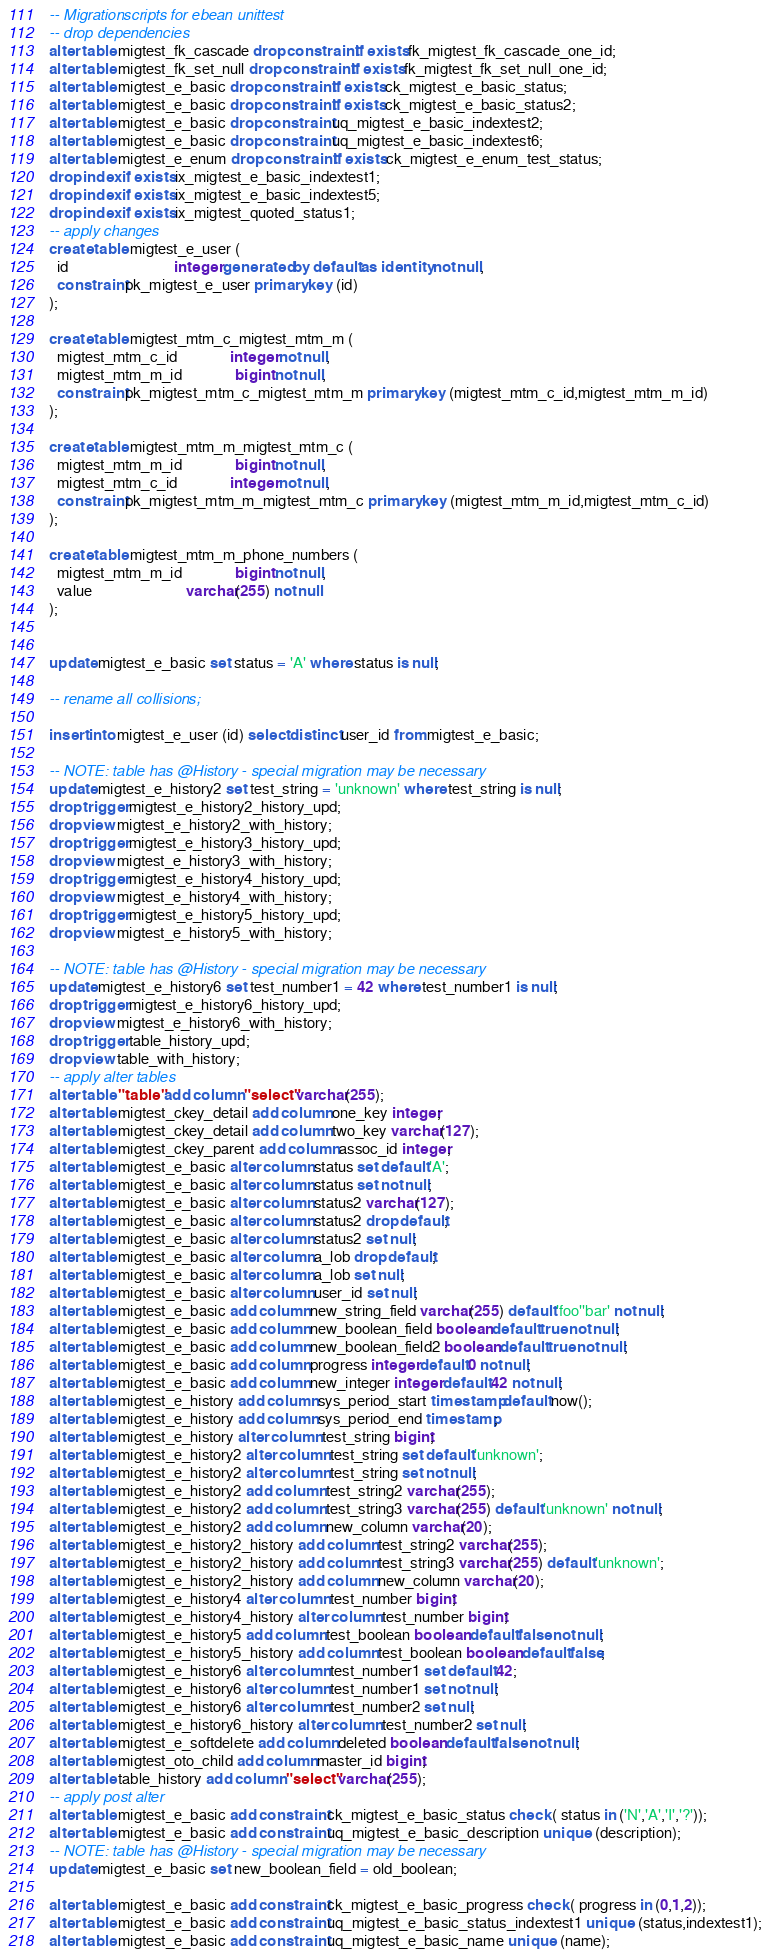Convert code to text. <code><loc_0><loc_0><loc_500><loc_500><_SQL_>-- Migrationscripts for ebean unittest
-- drop dependencies
alter table migtest_fk_cascade drop constraint if exists fk_migtest_fk_cascade_one_id;
alter table migtest_fk_set_null drop constraint if exists fk_migtest_fk_set_null_one_id;
alter table migtest_e_basic drop constraint if exists ck_migtest_e_basic_status;
alter table migtest_e_basic drop constraint if exists ck_migtest_e_basic_status2;
alter table migtest_e_basic drop constraint uq_migtest_e_basic_indextest2;
alter table migtest_e_basic drop constraint uq_migtest_e_basic_indextest6;
alter table migtest_e_enum drop constraint if exists ck_migtest_e_enum_test_status;
drop index if exists ix_migtest_e_basic_indextest1;
drop index if exists ix_migtest_e_basic_indextest5;
drop index if exists ix_migtest_quoted_status1;
-- apply changes
create table migtest_e_user (
  id                            integer generated by default as identity not null,
  constraint pk_migtest_e_user primary key (id)
);

create table migtest_mtm_c_migtest_mtm_m (
  migtest_mtm_c_id              integer not null,
  migtest_mtm_m_id              bigint not null,
  constraint pk_migtest_mtm_c_migtest_mtm_m primary key (migtest_mtm_c_id,migtest_mtm_m_id)
);

create table migtest_mtm_m_migtest_mtm_c (
  migtest_mtm_m_id              bigint not null,
  migtest_mtm_c_id              integer not null,
  constraint pk_migtest_mtm_m_migtest_mtm_c primary key (migtest_mtm_m_id,migtest_mtm_c_id)
);

create table migtest_mtm_m_phone_numbers (
  migtest_mtm_m_id              bigint not null,
  value                         varchar(255) not null
);


update migtest_e_basic set status = 'A' where status is null;

-- rename all collisions;

insert into migtest_e_user (id) select distinct user_id from migtest_e_basic;

-- NOTE: table has @History - special migration may be necessary
update migtest_e_history2 set test_string = 'unknown' where test_string is null;
drop trigger migtest_e_history2_history_upd;
drop view migtest_e_history2_with_history;
drop trigger migtest_e_history3_history_upd;
drop view migtest_e_history3_with_history;
drop trigger migtest_e_history4_history_upd;
drop view migtest_e_history4_with_history;
drop trigger migtest_e_history5_history_upd;
drop view migtest_e_history5_with_history;

-- NOTE: table has @History - special migration may be necessary
update migtest_e_history6 set test_number1 = 42 where test_number1 is null;
drop trigger migtest_e_history6_history_upd;
drop view migtest_e_history6_with_history;
drop trigger table_history_upd;
drop view table_with_history;
-- apply alter tables
alter table "table" add column "select" varchar(255);
alter table migtest_ckey_detail add column one_key integer;
alter table migtest_ckey_detail add column two_key varchar(127);
alter table migtest_ckey_parent add column assoc_id integer;
alter table migtest_e_basic alter column status set default 'A';
alter table migtest_e_basic alter column status set not null;
alter table migtest_e_basic alter column status2 varchar(127);
alter table migtest_e_basic alter column status2 drop default;
alter table migtest_e_basic alter column status2 set null;
alter table migtest_e_basic alter column a_lob drop default;
alter table migtest_e_basic alter column a_lob set null;
alter table migtest_e_basic alter column user_id set null;
alter table migtest_e_basic add column new_string_field varchar(255) default 'foo''bar' not null;
alter table migtest_e_basic add column new_boolean_field boolean default true not null;
alter table migtest_e_basic add column new_boolean_field2 boolean default true not null;
alter table migtest_e_basic add column progress integer default 0 not null;
alter table migtest_e_basic add column new_integer integer default 42 not null;
alter table migtest_e_history add column sys_period_start timestamp default now();
alter table migtest_e_history add column sys_period_end timestamp;
alter table migtest_e_history alter column test_string bigint;
alter table migtest_e_history2 alter column test_string set default 'unknown';
alter table migtest_e_history2 alter column test_string set not null;
alter table migtest_e_history2 add column test_string2 varchar(255);
alter table migtest_e_history2 add column test_string3 varchar(255) default 'unknown' not null;
alter table migtest_e_history2 add column new_column varchar(20);
alter table migtest_e_history2_history add column test_string2 varchar(255);
alter table migtest_e_history2_history add column test_string3 varchar(255) default 'unknown';
alter table migtest_e_history2_history add column new_column varchar(20);
alter table migtest_e_history4 alter column test_number bigint;
alter table migtest_e_history4_history alter column test_number bigint;
alter table migtest_e_history5 add column test_boolean boolean default false not null;
alter table migtest_e_history5_history add column test_boolean boolean default false;
alter table migtest_e_history6 alter column test_number1 set default 42;
alter table migtest_e_history6 alter column test_number1 set not null;
alter table migtest_e_history6 alter column test_number2 set null;
alter table migtest_e_history6_history alter column test_number2 set null;
alter table migtest_e_softdelete add column deleted boolean default false not null;
alter table migtest_oto_child add column master_id bigint;
alter table table_history add column "select" varchar(255);
-- apply post alter
alter table migtest_e_basic add constraint ck_migtest_e_basic_status check ( status in ('N','A','I','?'));
alter table migtest_e_basic add constraint uq_migtest_e_basic_description unique  (description);
-- NOTE: table has @History - special migration may be necessary
update migtest_e_basic set new_boolean_field = old_boolean;

alter table migtest_e_basic add constraint ck_migtest_e_basic_progress check ( progress in (0,1,2));
alter table migtest_e_basic add constraint uq_migtest_e_basic_status_indextest1 unique  (status,indextest1);
alter table migtest_e_basic add constraint uq_migtest_e_basic_name unique  (name);</code> 